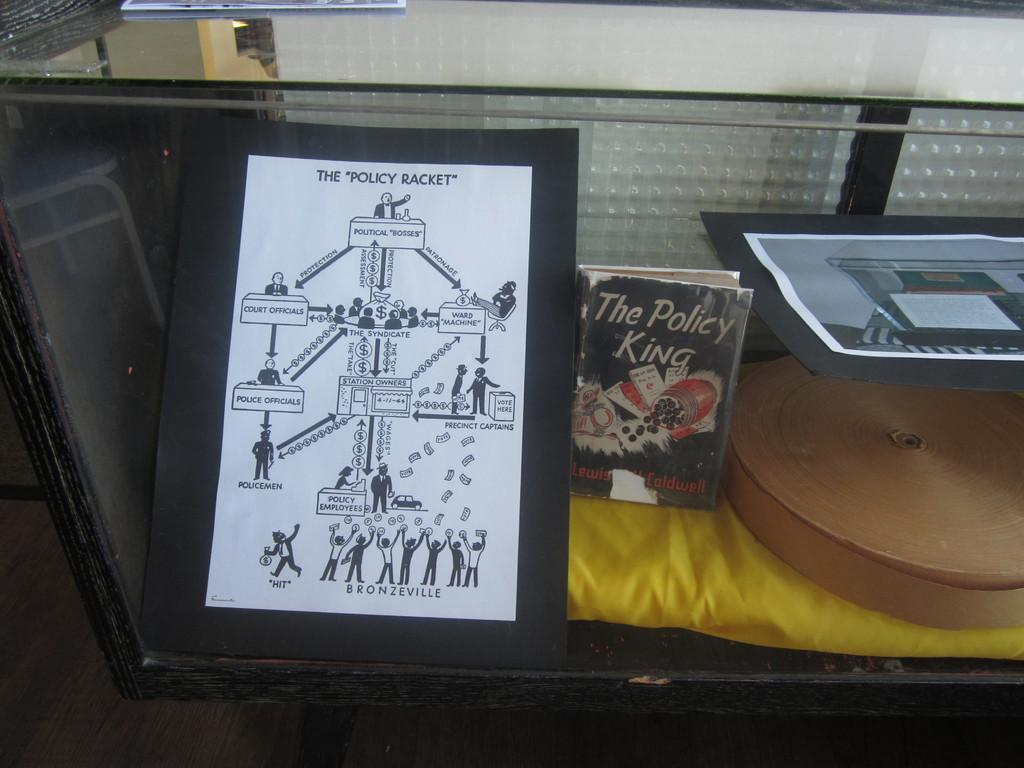What objects are present in the image? There are books in the image. How are the books arranged in the image? The books are placed in a rack. What material is used for the top of the rack? The top of the rack is made of glass. Is there a hen sitting on top of the books in the image? No, there is no hen present in the image. The books are placed in a rack, and the top of the rack is made of glass. 